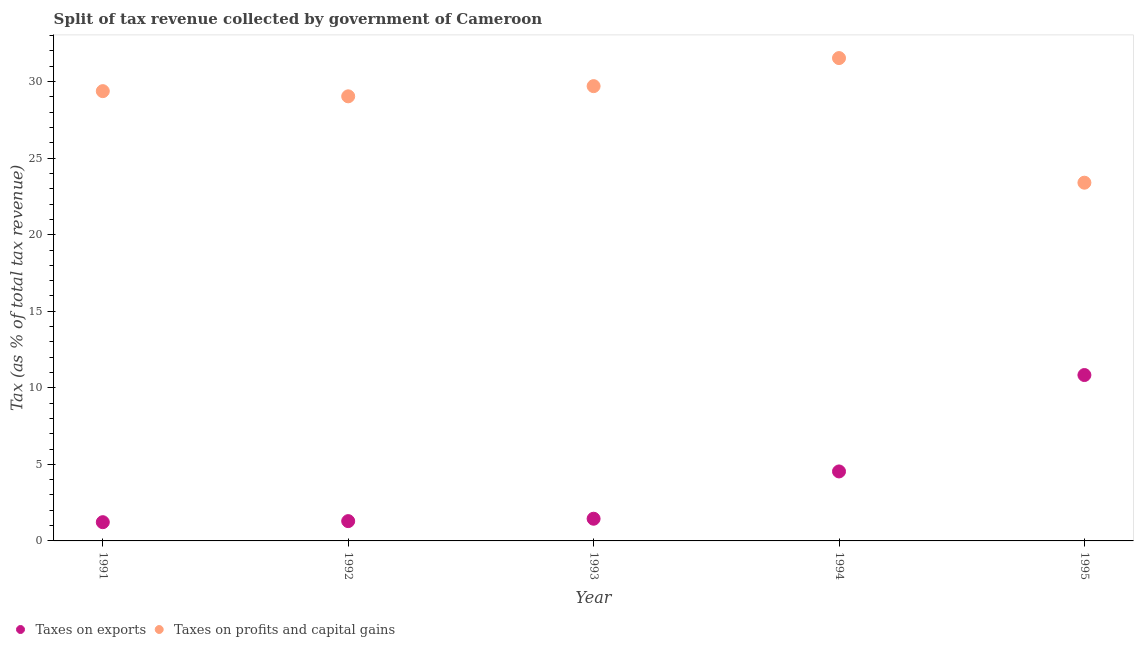Is the number of dotlines equal to the number of legend labels?
Ensure brevity in your answer.  Yes. What is the percentage of revenue obtained from taxes on exports in 1993?
Provide a short and direct response. 1.45. Across all years, what is the maximum percentage of revenue obtained from taxes on exports?
Provide a short and direct response. 10.83. Across all years, what is the minimum percentage of revenue obtained from taxes on profits and capital gains?
Your response must be concise. 23.4. In which year was the percentage of revenue obtained from taxes on profits and capital gains maximum?
Ensure brevity in your answer.  1994. In which year was the percentage of revenue obtained from taxes on profits and capital gains minimum?
Your answer should be compact. 1995. What is the total percentage of revenue obtained from taxes on profits and capital gains in the graph?
Make the answer very short. 143.05. What is the difference between the percentage of revenue obtained from taxes on profits and capital gains in 1991 and that in 1994?
Keep it short and to the point. -2.16. What is the difference between the percentage of revenue obtained from taxes on profits and capital gains in 1993 and the percentage of revenue obtained from taxes on exports in 1991?
Keep it short and to the point. 28.48. What is the average percentage of revenue obtained from taxes on profits and capital gains per year?
Your answer should be compact. 28.61. In the year 1993, what is the difference between the percentage of revenue obtained from taxes on exports and percentage of revenue obtained from taxes on profits and capital gains?
Provide a succinct answer. -28.25. In how many years, is the percentage of revenue obtained from taxes on profits and capital gains greater than 30 %?
Give a very brief answer. 1. What is the ratio of the percentage of revenue obtained from taxes on profits and capital gains in 1991 to that in 1994?
Offer a very short reply. 0.93. Is the percentage of revenue obtained from taxes on exports in 1992 less than that in 1995?
Your response must be concise. Yes. What is the difference between the highest and the second highest percentage of revenue obtained from taxes on exports?
Keep it short and to the point. 6.3. What is the difference between the highest and the lowest percentage of revenue obtained from taxes on exports?
Provide a succinct answer. 9.61. Is the sum of the percentage of revenue obtained from taxes on profits and capital gains in 1994 and 1995 greater than the maximum percentage of revenue obtained from taxes on exports across all years?
Provide a short and direct response. Yes. Is the percentage of revenue obtained from taxes on profits and capital gains strictly less than the percentage of revenue obtained from taxes on exports over the years?
Offer a very short reply. No. How many dotlines are there?
Provide a succinct answer. 2. How many years are there in the graph?
Provide a succinct answer. 5. What is the difference between two consecutive major ticks on the Y-axis?
Provide a short and direct response. 5. Are the values on the major ticks of Y-axis written in scientific E-notation?
Offer a very short reply. No. Does the graph contain grids?
Your response must be concise. No. How many legend labels are there?
Keep it short and to the point. 2. What is the title of the graph?
Keep it short and to the point. Split of tax revenue collected by government of Cameroon. Does "% of GNI" appear as one of the legend labels in the graph?
Your response must be concise. No. What is the label or title of the X-axis?
Ensure brevity in your answer.  Year. What is the label or title of the Y-axis?
Make the answer very short. Tax (as % of total tax revenue). What is the Tax (as % of total tax revenue) of Taxes on exports in 1991?
Your response must be concise. 1.22. What is the Tax (as % of total tax revenue) of Taxes on profits and capital gains in 1991?
Ensure brevity in your answer.  29.38. What is the Tax (as % of total tax revenue) in Taxes on exports in 1992?
Make the answer very short. 1.29. What is the Tax (as % of total tax revenue) in Taxes on profits and capital gains in 1992?
Give a very brief answer. 29.04. What is the Tax (as % of total tax revenue) of Taxes on exports in 1993?
Make the answer very short. 1.45. What is the Tax (as % of total tax revenue) in Taxes on profits and capital gains in 1993?
Provide a succinct answer. 29.7. What is the Tax (as % of total tax revenue) in Taxes on exports in 1994?
Your answer should be very brief. 4.54. What is the Tax (as % of total tax revenue) of Taxes on profits and capital gains in 1994?
Offer a very short reply. 31.54. What is the Tax (as % of total tax revenue) in Taxes on exports in 1995?
Your answer should be compact. 10.83. What is the Tax (as % of total tax revenue) in Taxes on profits and capital gains in 1995?
Ensure brevity in your answer.  23.4. Across all years, what is the maximum Tax (as % of total tax revenue) of Taxes on exports?
Keep it short and to the point. 10.83. Across all years, what is the maximum Tax (as % of total tax revenue) in Taxes on profits and capital gains?
Your answer should be compact. 31.54. Across all years, what is the minimum Tax (as % of total tax revenue) in Taxes on exports?
Keep it short and to the point. 1.22. Across all years, what is the minimum Tax (as % of total tax revenue) of Taxes on profits and capital gains?
Provide a succinct answer. 23.4. What is the total Tax (as % of total tax revenue) in Taxes on exports in the graph?
Your answer should be very brief. 19.34. What is the total Tax (as % of total tax revenue) of Taxes on profits and capital gains in the graph?
Keep it short and to the point. 143.05. What is the difference between the Tax (as % of total tax revenue) of Taxes on exports in 1991 and that in 1992?
Provide a succinct answer. -0.07. What is the difference between the Tax (as % of total tax revenue) of Taxes on profits and capital gains in 1991 and that in 1992?
Keep it short and to the point. 0.34. What is the difference between the Tax (as % of total tax revenue) of Taxes on exports in 1991 and that in 1993?
Make the answer very short. -0.23. What is the difference between the Tax (as % of total tax revenue) in Taxes on profits and capital gains in 1991 and that in 1993?
Provide a succinct answer. -0.33. What is the difference between the Tax (as % of total tax revenue) in Taxes on exports in 1991 and that in 1994?
Keep it short and to the point. -3.31. What is the difference between the Tax (as % of total tax revenue) in Taxes on profits and capital gains in 1991 and that in 1994?
Offer a terse response. -2.16. What is the difference between the Tax (as % of total tax revenue) in Taxes on exports in 1991 and that in 1995?
Your response must be concise. -9.61. What is the difference between the Tax (as % of total tax revenue) in Taxes on profits and capital gains in 1991 and that in 1995?
Provide a succinct answer. 5.98. What is the difference between the Tax (as % of total tax revenue) in Taxes on exports in 1992 and that in 1993?
Your answer should be very brief. -0.16. What is the difference between the Tax (as % of total tax revenue) in Taxes on profits and capital gains in 1992 and that in 1993?
Keep it short and to the point. -0.67. What is the difference between the Tax (as % of total tax revenue) in Taxes on exports in 1992 and that in 1994?
Your answer should be compact. -3.24. What is the difference between the Tax (as % of total tax revenue) of Taxes on profits and capital gains in 1992 and that in 1994?
Keep it short and to the point. -2.5. What is the difference between the Tax (as % of total tax revenue) of Taxes on exports in 1992 and that in 1995?
Keep it short and to the point. -9.54. What is the difference between the Tax (as % of total tax revenue) in Taxes on profits and capital gains in 1992 and that in 1995?
Give a very brief answer. 5.64. What is the difference between the Tax (as % of total tax revenue) of Taxes on exports in 1993 and that in 1994?
Make the answer very short. -3.09. What is the difference between the Tax (as % of total tax revenue) of Taxes on profits and capital gains in 1993 and that in 1994?
Offer a very short reply. -1.83. What is the difference between the Tax (as % of total tax revenue) of Taxes on exports in 1993 and that in 1995?
Keep it short and to the point. -9.39. What is the difference between the Tax (as % of total tax revenue) of Taxes on profits and capital gains in 1993 and that in 1995?
Offer a terse response. 6.31. What is the difference between the Tax (as % of total tax revenue) in Taxes on exports in 1994 and that in 1995?
Offer a terse response. -6.3. What is the difference between the Tax (as % of total tax revenue) in Taxes on profits and capital gains in 1994 and that in 1995?
Your answer should be very brief. 8.14. What is the difference between the Tax (as % of total tax revenue) of Taxes on exports in 1991 and the Tax (as % of total tax revenue) of Taxes on profits and capital gains in 1992?
Your response must be concise. -27.81. What is the difference between the Tax (as % of total tax revenue) of Taxes on exports in 1991 and the Tax (as % of total tax revenue) of Taxes on profits and capital gains in 1993?
Provide a short and direct response. -28.48. What is the difference between the Tax (as % of total tax revenue) in Taxes on exports in 1991 and the Tax (as % of total tax revenue) in Taxes on profits and capital gains in 1994?
Offer a very short reply. -30.31. What is the difference between the Tax (as % of total tax revenue) of Taxes on exports in 1991 and the Tax (as % of total tax revenue) of Taxes on profits and capital gains in 1995?
Ensure brevity in your answer.  -22.17. What is the difference between the Tax (as % of total tax revenue) of Taxes on exports in 1992 and the Tax (as % of total tax revenue) of Taxes on profits and capital gains in 1993?
Provide a short and direct response. -28.41. What is the difference between the Tax (as % of total tax revenue) of Taxes on exports in 1992 and the Tax (as % of total tax revenue) of Taxes on profits and capital gains in 1994?
Your response must be concise. -30.24. What is the difference between the Tax (as % of total tax revenue) in Taxes on exports in 1992 and the Tax (as % of total tax revenue) in Taxes on profits and capital gains in 1995?
Make the answer very short. -22.1. What is the difference between the Tax (as % of total tax revenue) in Taxes on exports in 1993 and the Tax (as % of total tax revenue) in Taxes on profits and capital gains in 1994?
Keep it short and to the point. -30.09. What is the difference between the Tax (as % of total tax revenue) in Taxes on exports in 1993 and the Tax (as % of total tax revenue) in Taxes on profits and capital gains in 1995?
Ensure brevity in your answer.  -21.95. What is the difference between the Tax (as % of total tax revenue) of Taxes on exports in 1994 and the Tax (as % of total tax revenue) of Taxes on profits and capital gains in 1995?
Offer a very short reply. -18.86. What is the average Tax (as % of total tax revenue) in Taxes on exports per year?
Your response must be concise. 3.87. What is the average Tax (as % of total tax revenue) of Taxes on profits and capital gains per year?
Offer a very short reply. 28.61. In the year 1991, what is the difference between the Tax (as % of total tax revenue) in Taxes on exports and Tax (as % of total tax revenue) in Taxes on profits and capital gains?
Offer a terse response. -28.15. In the year 1992, what is the difference between the Tax (as % of total tax revenue) of Taxes on exports and Tax (as % of total tax revenue) of Taxes on profits and capital gains?
Give a very brief answer. -27.75. In the year 1993, what is the difference between the Tax (as % of total tax revenue) in Taxes on exports and Tax (as % of total tax revenue) in Taxes on profits and capital gains?
Make the answer very short. -28.25. In the year 1994, what is the difference between the Tax (as % of total tax revenue) of Taxes on exports and Tax (as % of total tax revenue) of Taxes on profits and capital gains?
Provide a succinct answer. -27. In the year 1995, what is the difference between the Tax (as % of total tax revenue) of Taxes on exports and Tax (as % of total tax revenue) of Taxes on profits and capital gains?
Ensure brevity in your answer.  -12.56. What is the ratio of the Tax (as % of total tax revenue) in Taxes on exports in 1991 to that in 1992?
Give a very brief answer. 0.95. What is the ratio of the Tax (as % of total tax revenue) of Taxes on profits and capital gains in 1991 to that in 1992?
Provide a succinct answer. 1.01. What is the ratio of the Tax (as % of total tax revenue) in Taxes on exports in 1991 to that in 1993?
Your response must be concise. 0.84. What is the ratio of the Tax (as % of total tax revenue) in Taxes on profits and capital gains in 1991 to that in 1993?
Provide a succinct answer. 0.99. What is the ratio of the Tax (as % of total tax revenue) of Taxes on exports in 1991 to that in 1994?
Your response must be concise. 0.27. What is the ratio of the Tax (as % of total tax revenue) of Taxes on profits and capital gains in 1991 to that in 1994?
Offer a very short reply. 0.93. What is the ratio of the Tax (as % of total tax revenue) of Taxes on exports in 1991 to that in 1995?
Your answer should be compact. 0.11. What is the ratio of the Tax (as % of total tax revenue) in Taxes on profits and capital gains in 1991 to that in 1995?
Keep it short and to the point. 1.26. What is the ratio of the Tax (as % of total tax revenue) in Taxes on exports in 1992 to that in 1993?
Offer a terse response. 0.89. What is the ratio of the Tax (as % of total tax revenue) in Taxes on profits and capital gains in 1992 to that in 1993?
Offer a very short reply. 0.98. What is the ratio of the Tax (as % of total tax revenue) in Taxes on exports in 1992 to that in 1994?
Provide a short and direct response. 0.28. What is the ratio of the Tax (as % of total tax revenue) of Taxes on profits and capital gains in 1992 to that in 1994?
Ensure brevity in your answer.  0.92. What is the ratio of the Tax (as % of total tax revenue) in Taxes on exports in 1992 to that in 1995?
Provide a short and direct response. 0.12. What is the ratio of the Tax (as % of total tax revenue) in Taxes on profits and capital gains in 1992 to that in 1995?
Keep it short and to the point. 1.24. What is the ratio of the Tax (as % of total tax revenue) in Taxes on exports in 1993 to that in 1994?
Offer a terse response. 0.32. What is the ratio of the Tax (as % of total tax revenue) of Taxes on profits and capital gains in 1993 to that in 1994?
Give a very brief answer. 0.94. What is the ratio of the Tax (as % of total tax revenue) in Taxes on exports in 1993 to that in 1995?
Ensure brevity in your answer.  0.13. What is the ratio of the Tax (as % of total tax revenue) of Taxes on profits and capital gains in 1993 to that in 1995?
Your answer should be compact. 1.27. What is the ratio of the Tax (as % of total tax revenue) of Taxes on exports in 1994 to that in 1995?
Keep it short and to the point. 0.42. What is the ratio of the Tax (as % of total tax revenue) in Taxes on profits and capital gains in 1994 to that in 1995?
Provide a succinct answer. 1.35. What is the difference between the highest and the second highest Tax (as % of total tax revenue) of Taxes on exports?
Ensure brevity in your answer.  6.3. What is the difference between the highest and the second highest Tax (as % of total tax revenue) of Taxes on profits and capital gains?
Provide a succinct answer. 1.83. What is the difference between the highest and the lowest Tax (as % of total tax revenue) of Taxes on exports?
Give a very brief answer. 9.61. What is the difference between the highest and the lowest Tax (as % of total tax revenue) of Taxes on profits and capital gains?
Ensure brevity in your answer.  8.14. 